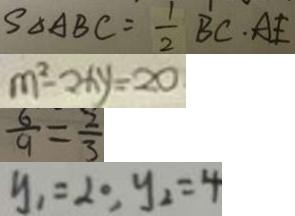Convert formula to latex. <formula><loc_0><loc_0><loc_500><loc_500>S _ { \Delta A B C } = \frac { 1 } { 2 } B C \cdot A E 
 m ^ { 2 } - 2 x y = 2 0 
 \frac { 6 } { 9 } = \frac { 2 } { 3 } 
 y _ { 1 } = 2 0 , y _ { 2 } = 4</formula> 